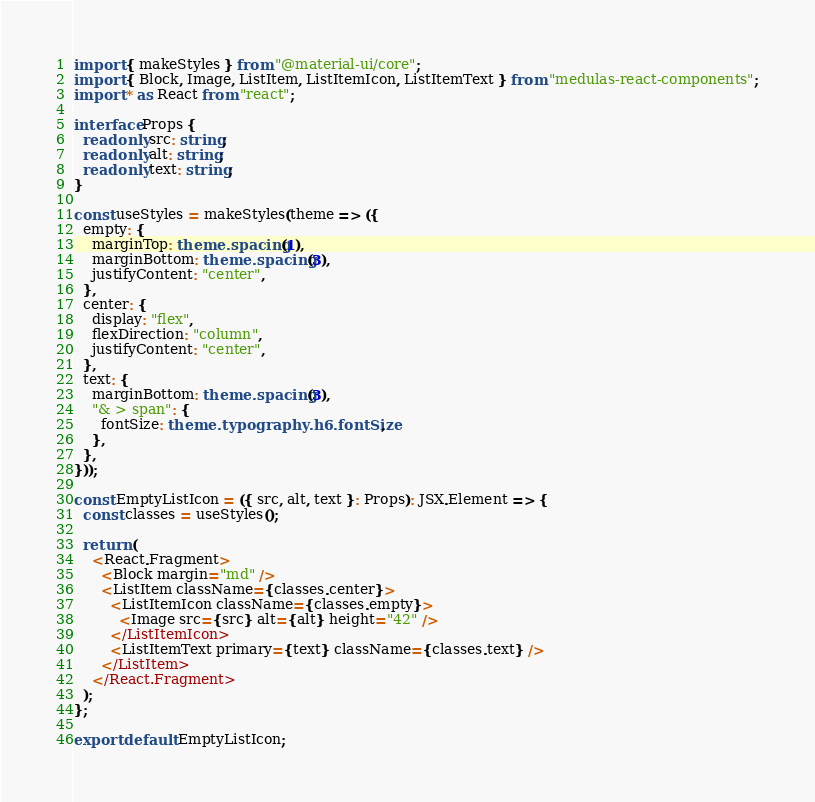<code> <loc_0><loc_0><loc_500><loc_500><_TypeScript_>import { makeStyles } from "@material-ui/core";
import { Block, Image, ListItem, ListItemIcon, ListItemText } from "medulas-react-components";
import * as React from "react";

interface Props {
  readonly src: string;
  readonly alt: string;
  readonly text: string;
}

const useStyles = makeStyles(theme => ({
  empty: {
    marginTop: theme.spacing(1),
    marginBottom: theme.spacing(3),
    justifyContent: "center",
  },
  center: {
    display: "flex",
    flexDirection: "column",
    justifyContent: "center",
  },
  text: {
    marginBottom: theme.spacing(3),
    "& > span": {
      fontSize: theme.typography.h6.fontSize,
    },
  },
}));

const EmptyListIcon = ({ src, alt, text }: Props): JSX.Element => {
  const classes = useStyles();

  return (
    <React.Fragment>
      <Block margin="md" />
      <ListItem className={classes.center}>
        <ListItemIcon className={classes.empty}>
          <Image src={src} alt={alt} height="42" />
        </ListItemIcon>
        <ListItemText primary={text} className={classes.text} />
      </ListItem>
    </React.Fragment>
  );
};

export default EmptyListIcon;
</code> 